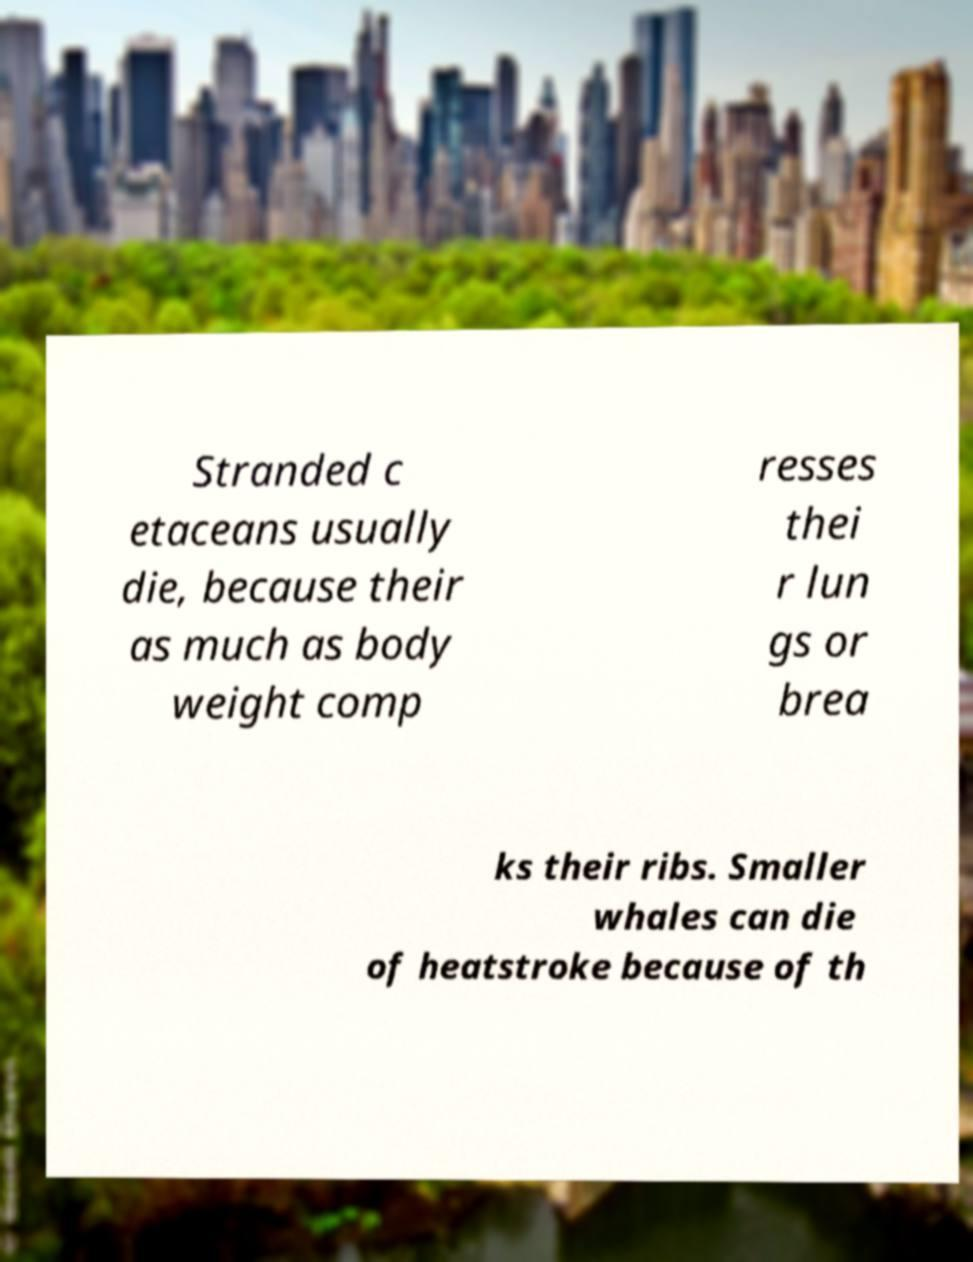For documentation purposes, I need the text within this image transcribed. Could you provide that? Stranded c etaceans usually die, because their as much as body weight comp resses thei r lun gs or brea ks their ribs. Smaller whales can die of heatstroke because of th 